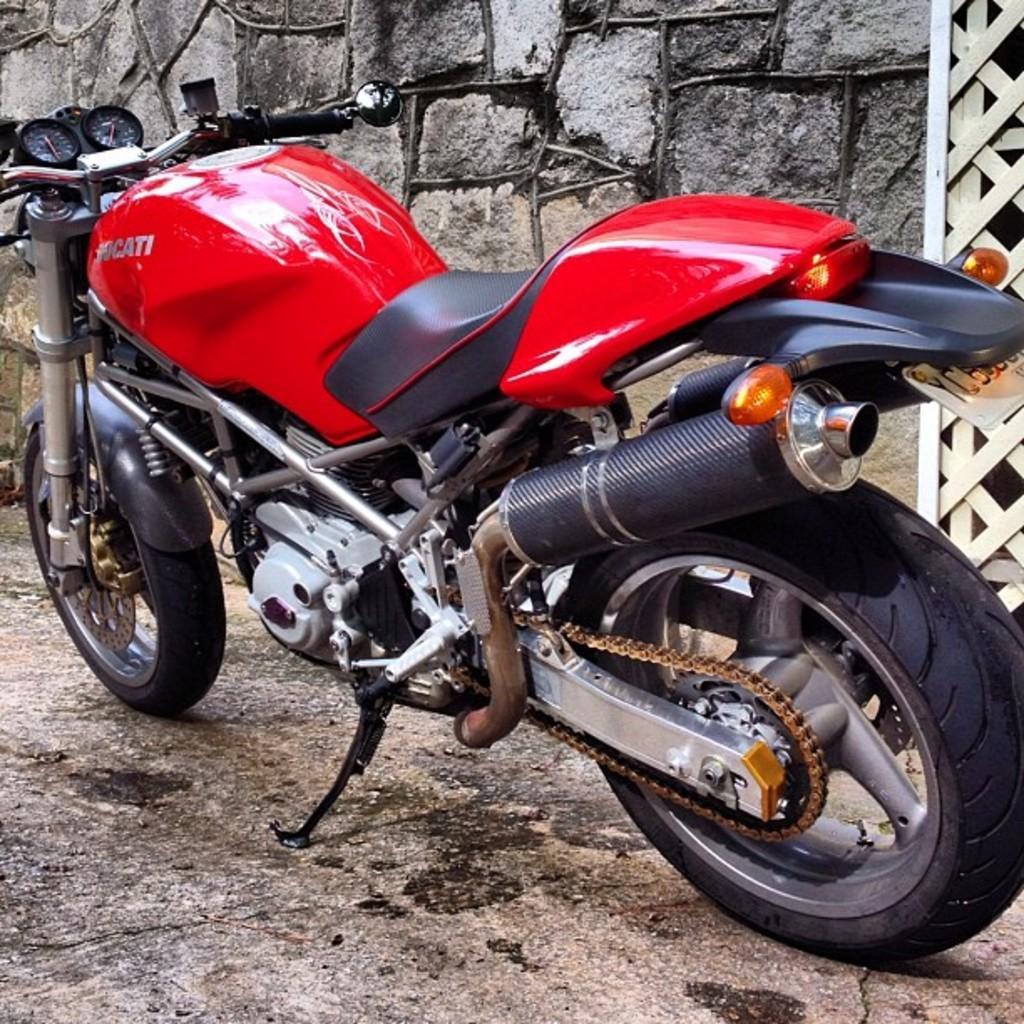How would you summarize this image in a sentence or two? This picture is clicked outside. In the center we can see a red color bike parked on the ground. In the background we can see the stone wall and some other objects. 